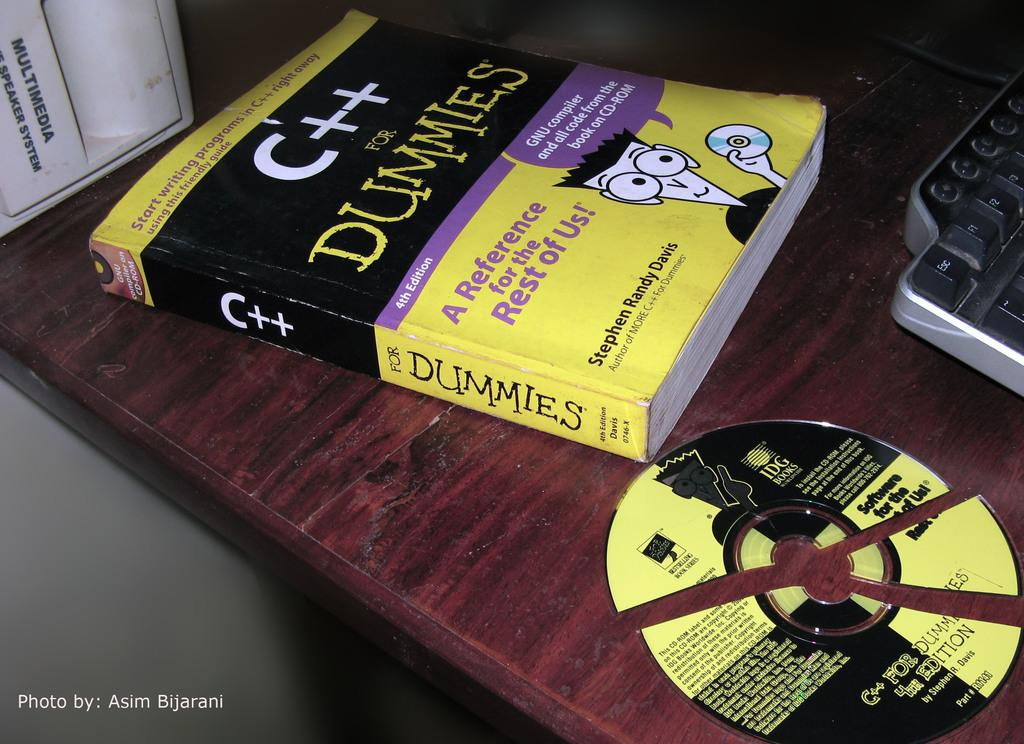Provide a one-sentence caption for the provided image. A desk with a book about a subject for dummies with a broken cd disc next to it. 